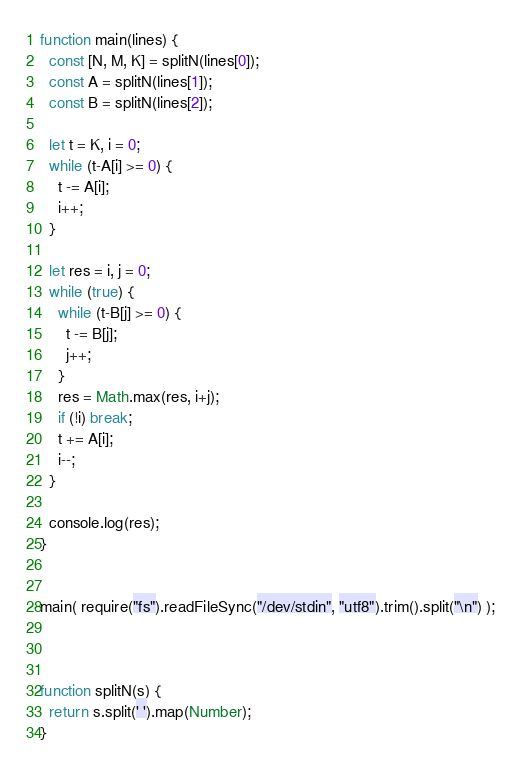<code> <loc_0><loc_0><loc_500><loc_500><_JavaScript_>function main(lines) {
  const [N, M, K] = splitN(lines[0]);
  const A = splitN(lines[1]);
  const B = splitN(lines[2]);
  
  let t = K, i = 0;
  while (t-A[i] >= 0) {
    t -= A[i];
    i++;
  }

  let res = i, j = 0;
  while (true) {
    while (t-B[j] >= 0) {
      t -= B[j];
      j++;
    }
    res = Math.max(res, i+j);
    if (!i) break;
    t += A[i];
    i--;
  }
  
  console.log(res);
}


main( require("fs").readFileSync("/dev/stdin", "utf8").trim().split("\n") );



function splitN(s) {
  return s.split(' ').map(Number);
}</code> 